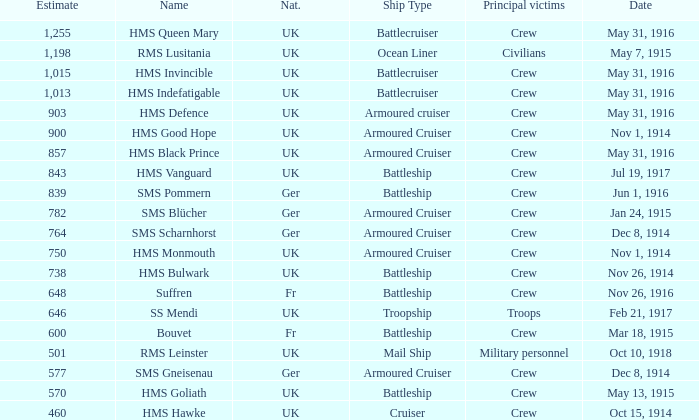What is the origin of the ship when the primary casualties are civilians? UK. 